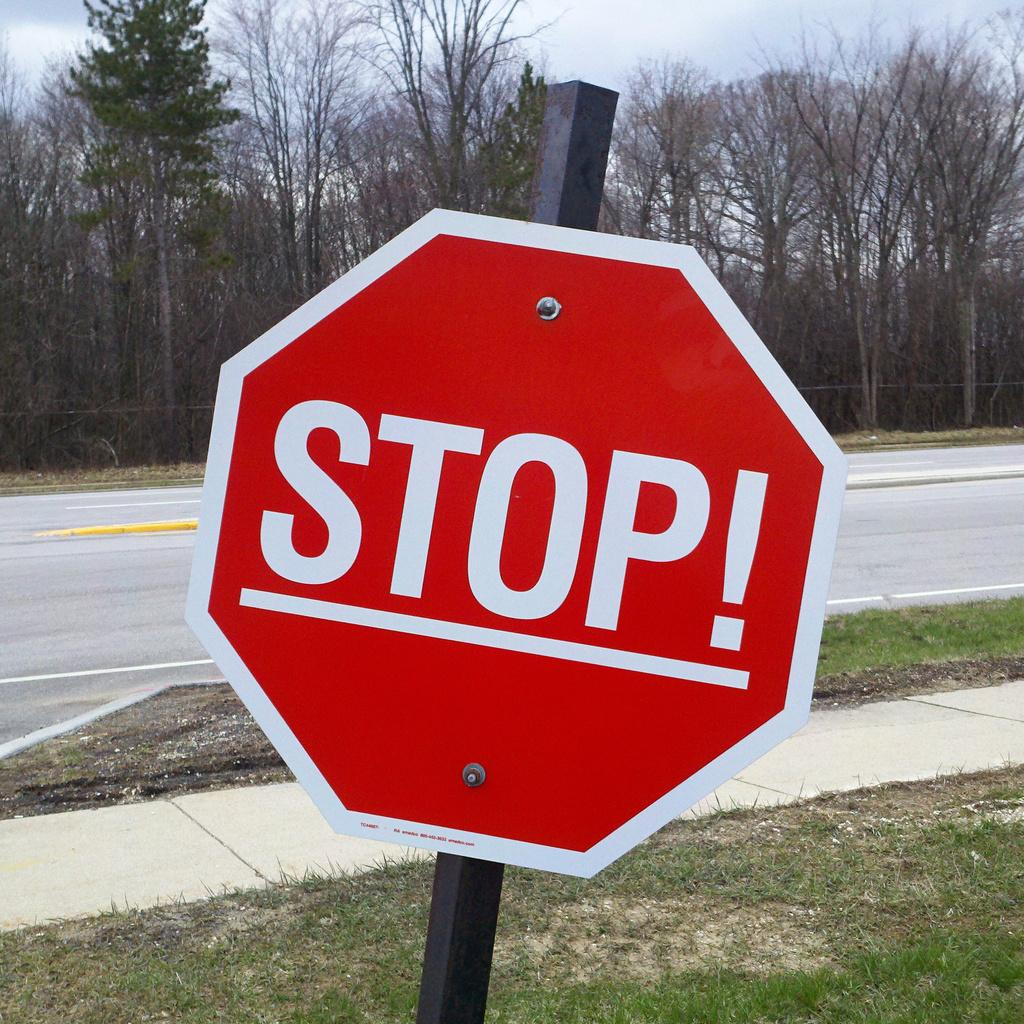Provide a one-sentence caption for the provided image. A stop sign has the addition of an exclamation point on it. 